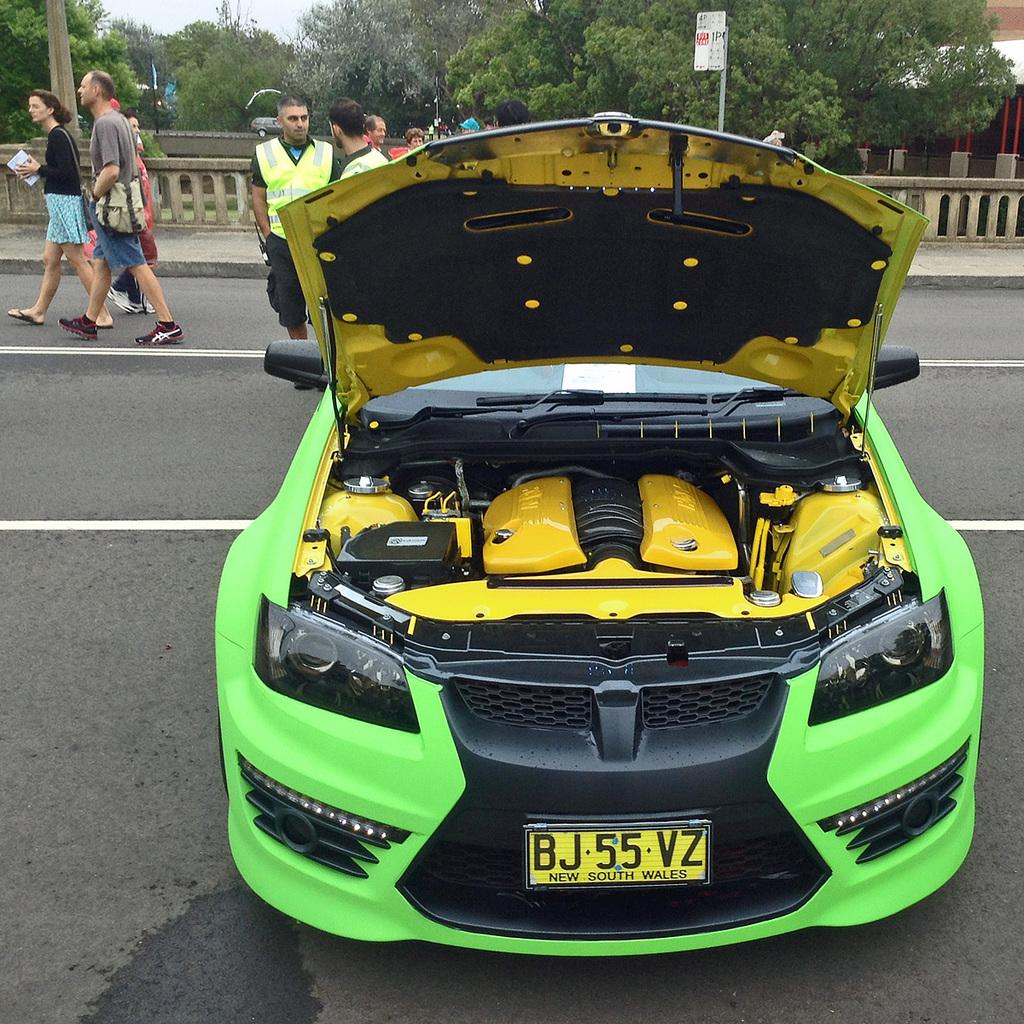What is the main subject of the image? There is a car in the image. What is the setting of the image? There is a road in the image. Can you describe the background of the image? There are people visible in the background. What is the purpose of the railing in the image? The railing is likely there for safety or to prevent people from falling. What type of vegetation can be seen in the image? There are trees in the image. What is the board on a pole used for in the image? The board on a pole might be used for displaying information or directions. What type of animals can be seen at the zoo in the image? There is no zoo present in the image, so it is not possible to determine what animals might be seen there. 